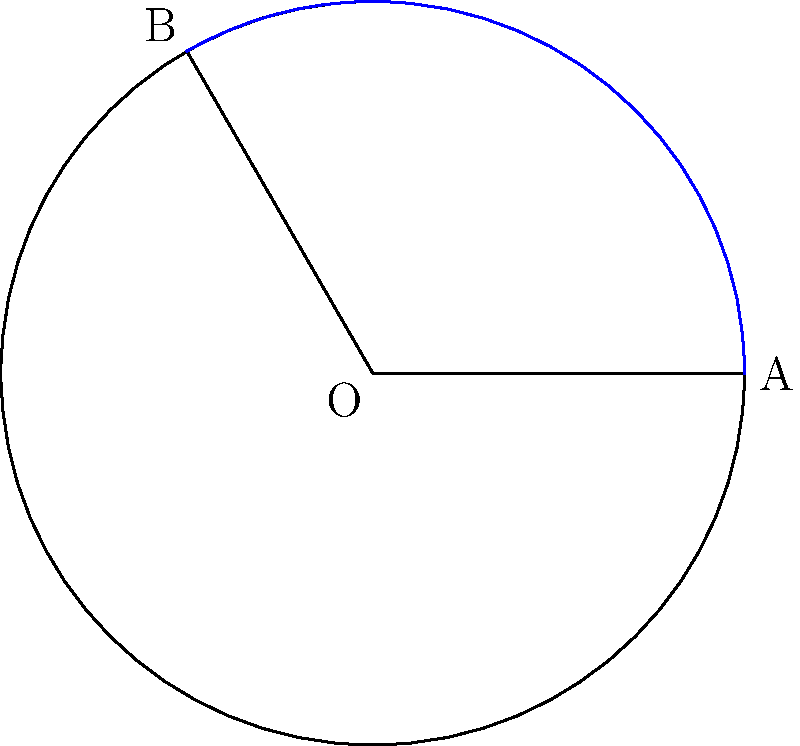In the figure above, a circular segment is formed by the arc AB and chord AB. Given that the radius OA = OB = 3 units and the central angle AOB is 120°, calculate the area of the circular segment. Round your answer to two decimal places. To find the area of the circular segment, we need to follow these steps:

1) The area of the circular segment is the difference between the area of the sector OAB and the area of triangle OAB.

2) Area of sector OAB:
   $$A_{sector} = \frac{\theta}{360°} \pi r^2$$
   Where $\theta$ is the central angle in degrees and $r$ is the radius.
   $$A_{sector} = \frac{120}{360} \pi 3^2 = \frac{1}{3} \pi 9 = 3\pi$$

3) Area of triangle OAB:
   We can use the formula: $A_{triangle} = \frac{1}{2}r^2 \sin \theta$
   $$A_{triangle} = \frac{1}{2} \cdot 3^2 \cdot \sin 120° = \frac{9}{2} \cdot \frac{\sqrt{3}}{2} = \frac{9\sqrt{3}}{4}$$

4) Area of segment = Area of sector - Area of triangle
   $$A_{segment} = 3\pi - \frac{9\sqrt{3}}{4}$$

5) Calculating and rounding to two decimal places:
   $$A_{segment} \approx 9.42 - 3.90 = 5.52$$

Therefore, the area of the circular segment is approximately 5.52 square units.
Answer: 5.52 square units 